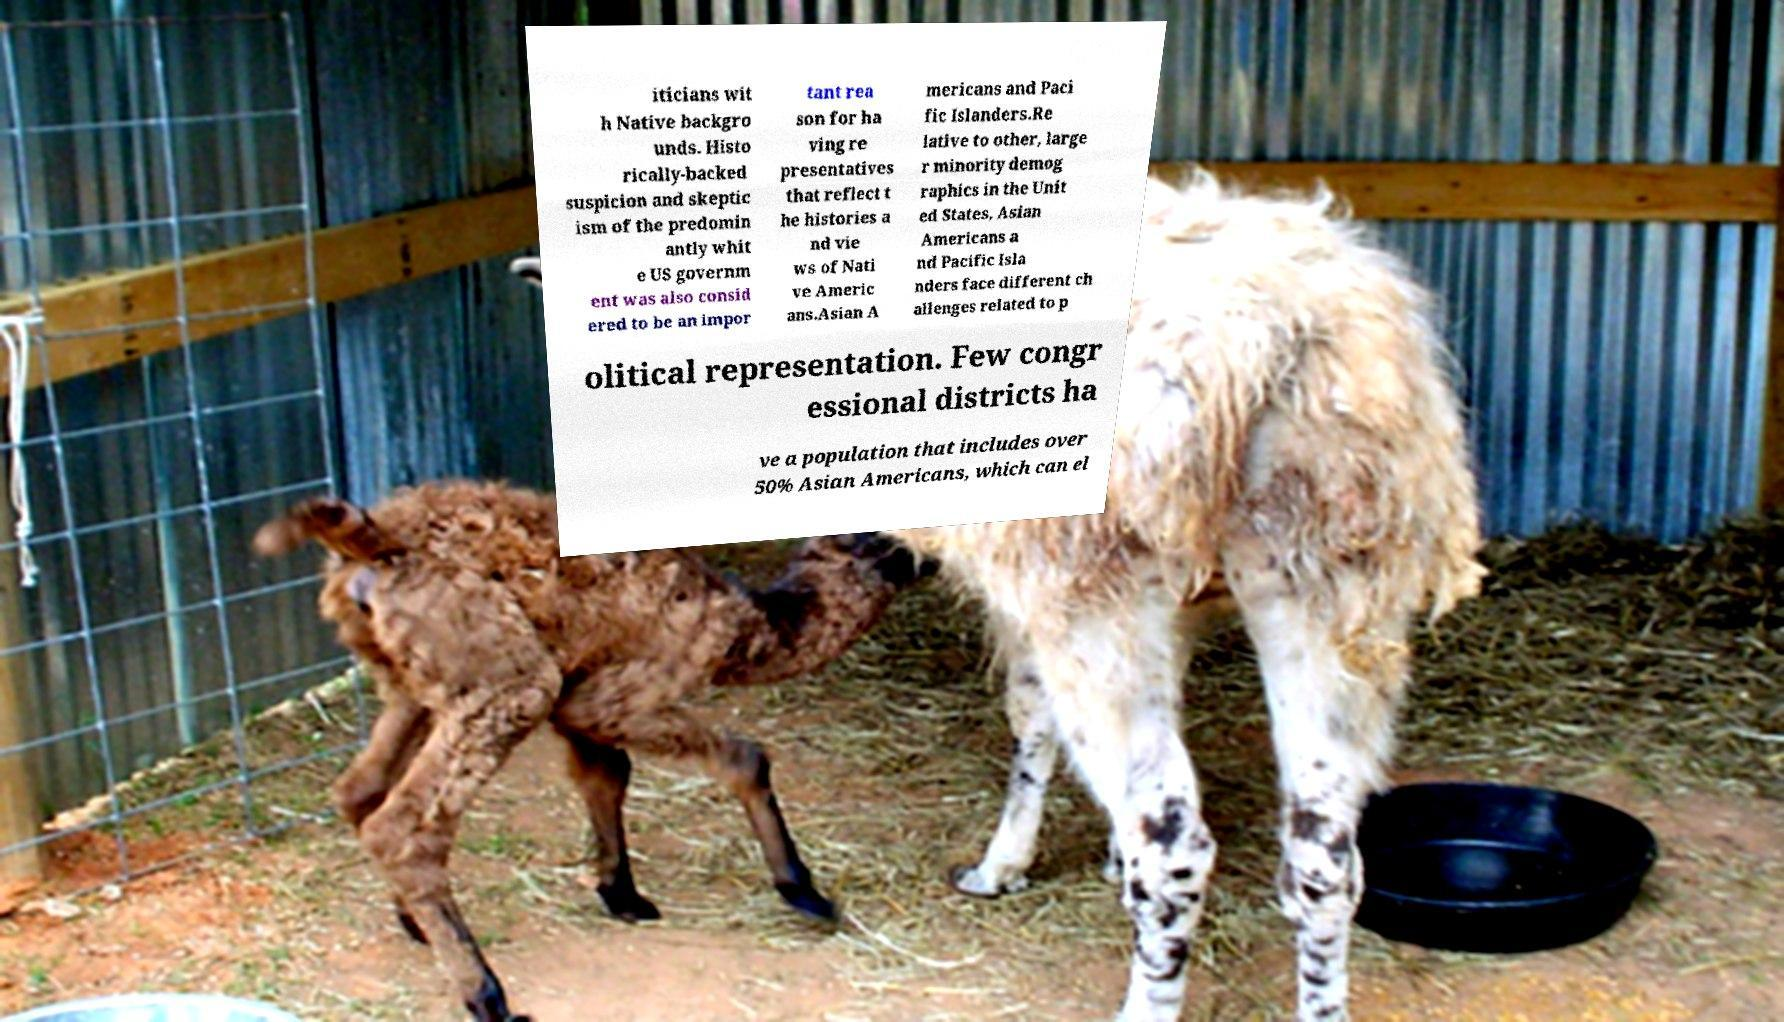Could you assist in decoding the text presented in this image and type it out clearly? iticians wit h Native backgro unds. Histo rically-backed suspicion and skeptic ism of the predomin antly whit e US governm ent was also consid ered to be an impor tant rea son for ha ving re presentatives that reflect t he histories a nd vie ws of Nati ve Americ ans.Asian A mericans and Paci fic Islanders.Re lative to other, large r minority demog raphics in the Unit ed States, Asian Americans a nd Pacific Isla nders face different ch allenges related to p olitical representation. Few congr essional districts ha ve a population that includes over 50% Asian Americans, which can el 